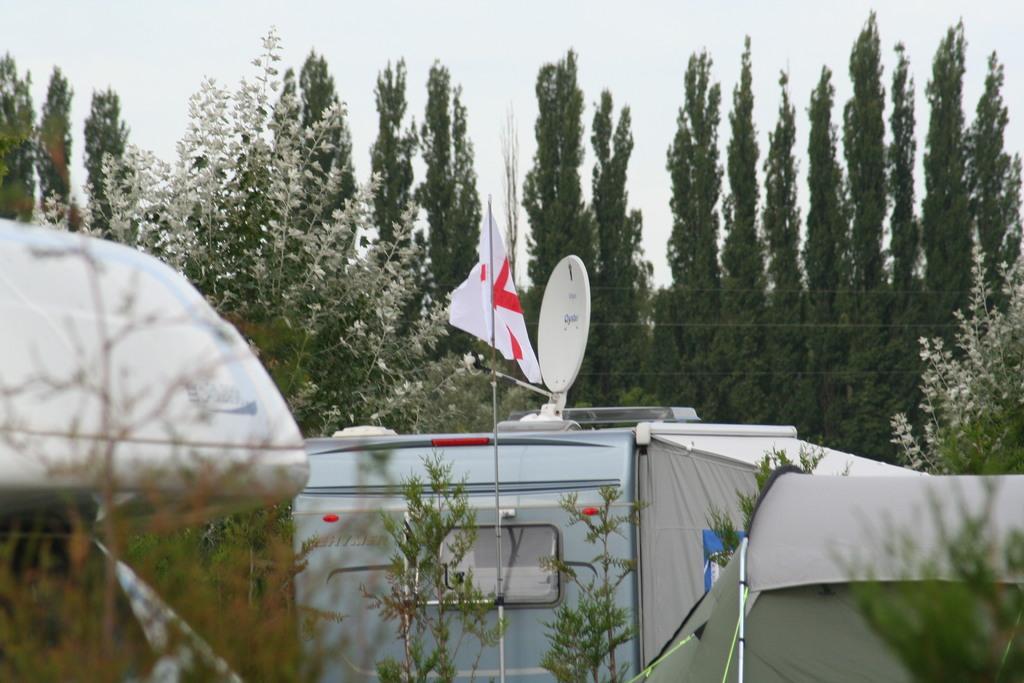How would you summarize this image in a sentence or two? In the center of the image we can see vehicle, flag and a dish. On the left side of the image there is a tree and vehicle. On the right side of the image we can see trees. In the background there are trees and sky. 